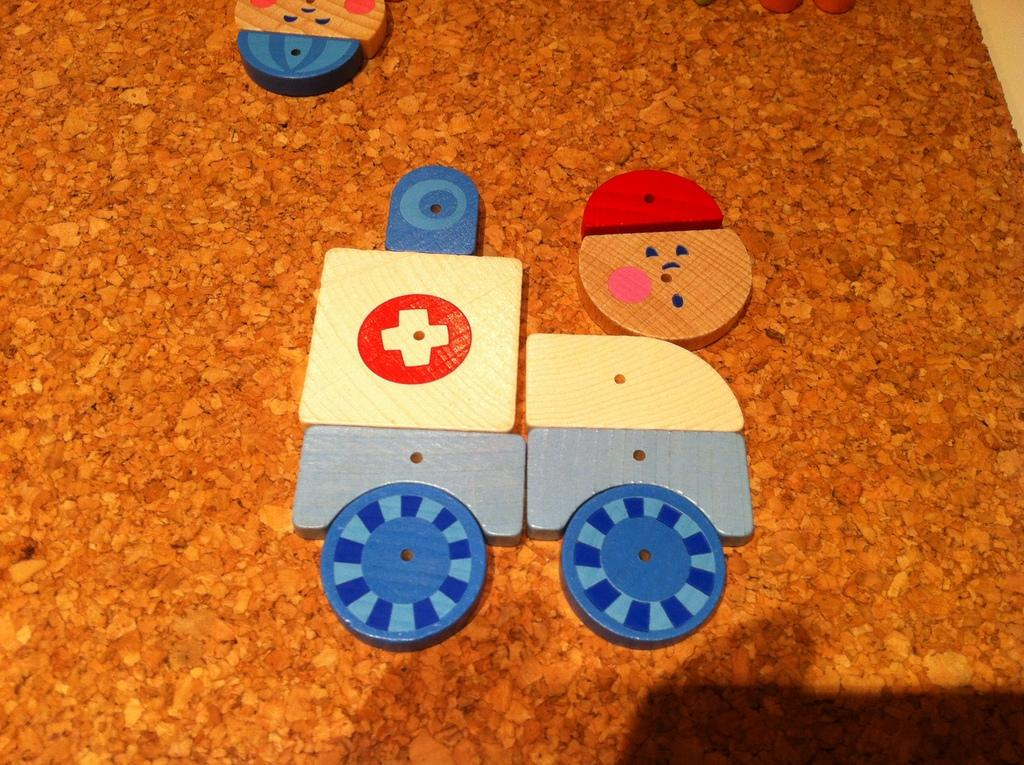What is the color of the surface in the image? The surface in the image is brown. What object is present on the brown surface? There is a toy vehicle in the image. How is the toy vehicle constructed? The toy vehicle is made with blocks. What type of paste is being used to stick the toy vehicle to the brown surface? There is no paste present in the image, and the toy vehicle is not being stuck to the brown surface. 